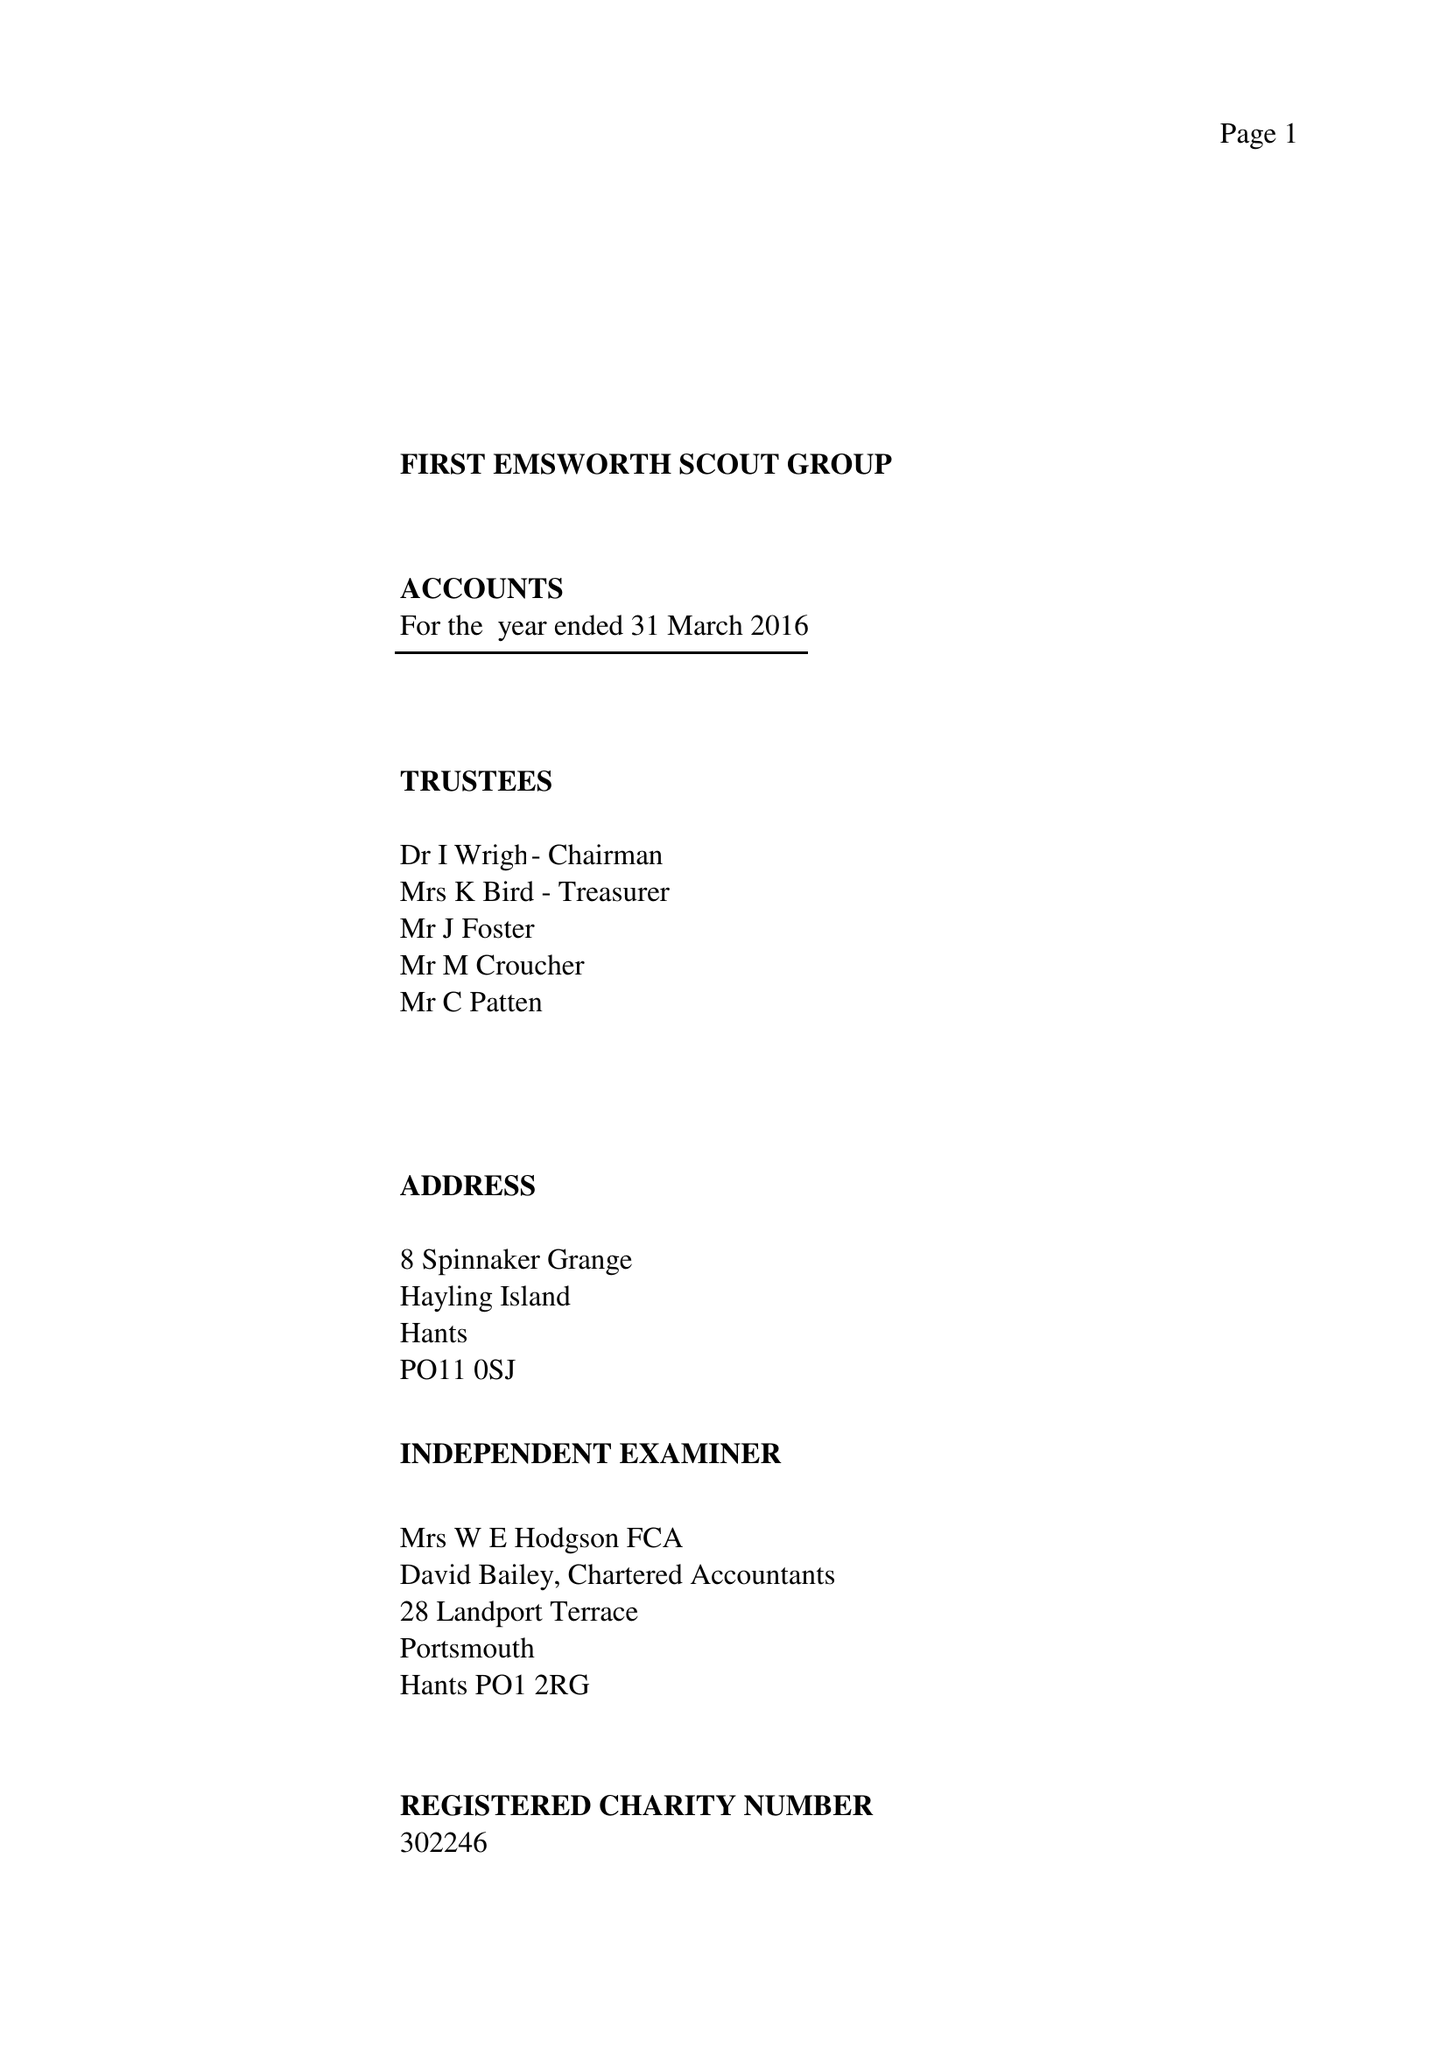What is the value for the charity_name?
Answer the question using a single word or phrase. First Emsworth Scout Group 